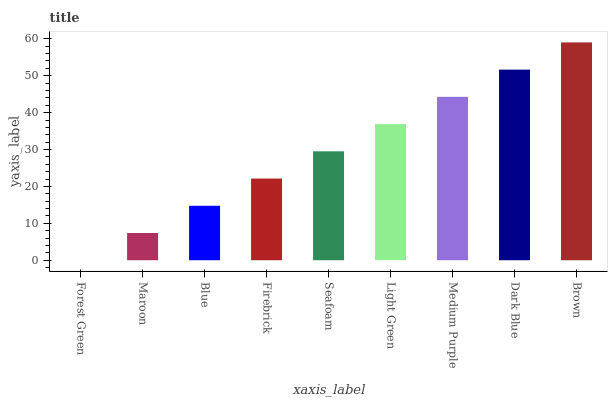Is Forest Green the minimum?
Answer yes or no. Yes. Is Brown the maximum?
Answer yes or no. Yes. Is Maroon the minimum?
Answer yes or no. No. Is Maroon the maximum?
Answer yes or no. No. Is Maroon greater than Forest Green?
Answer yes or no. Yes. Is Forest Green less than Maroon?
Answer yes or no. Yes. Is Forest Green greater than Maroon?
Answer yes or no. No. Is Maroon less than Forest Green?
Answer yes or no. No. Is Seafoam the high median?
Answer yes or no. Yes. Is Seafoam the low median?
Answer yes or no. Yes. Is Light Green the high median?
Answer yes or no. No. Is Medium Purple the low median?
Answer yes or no. No. 